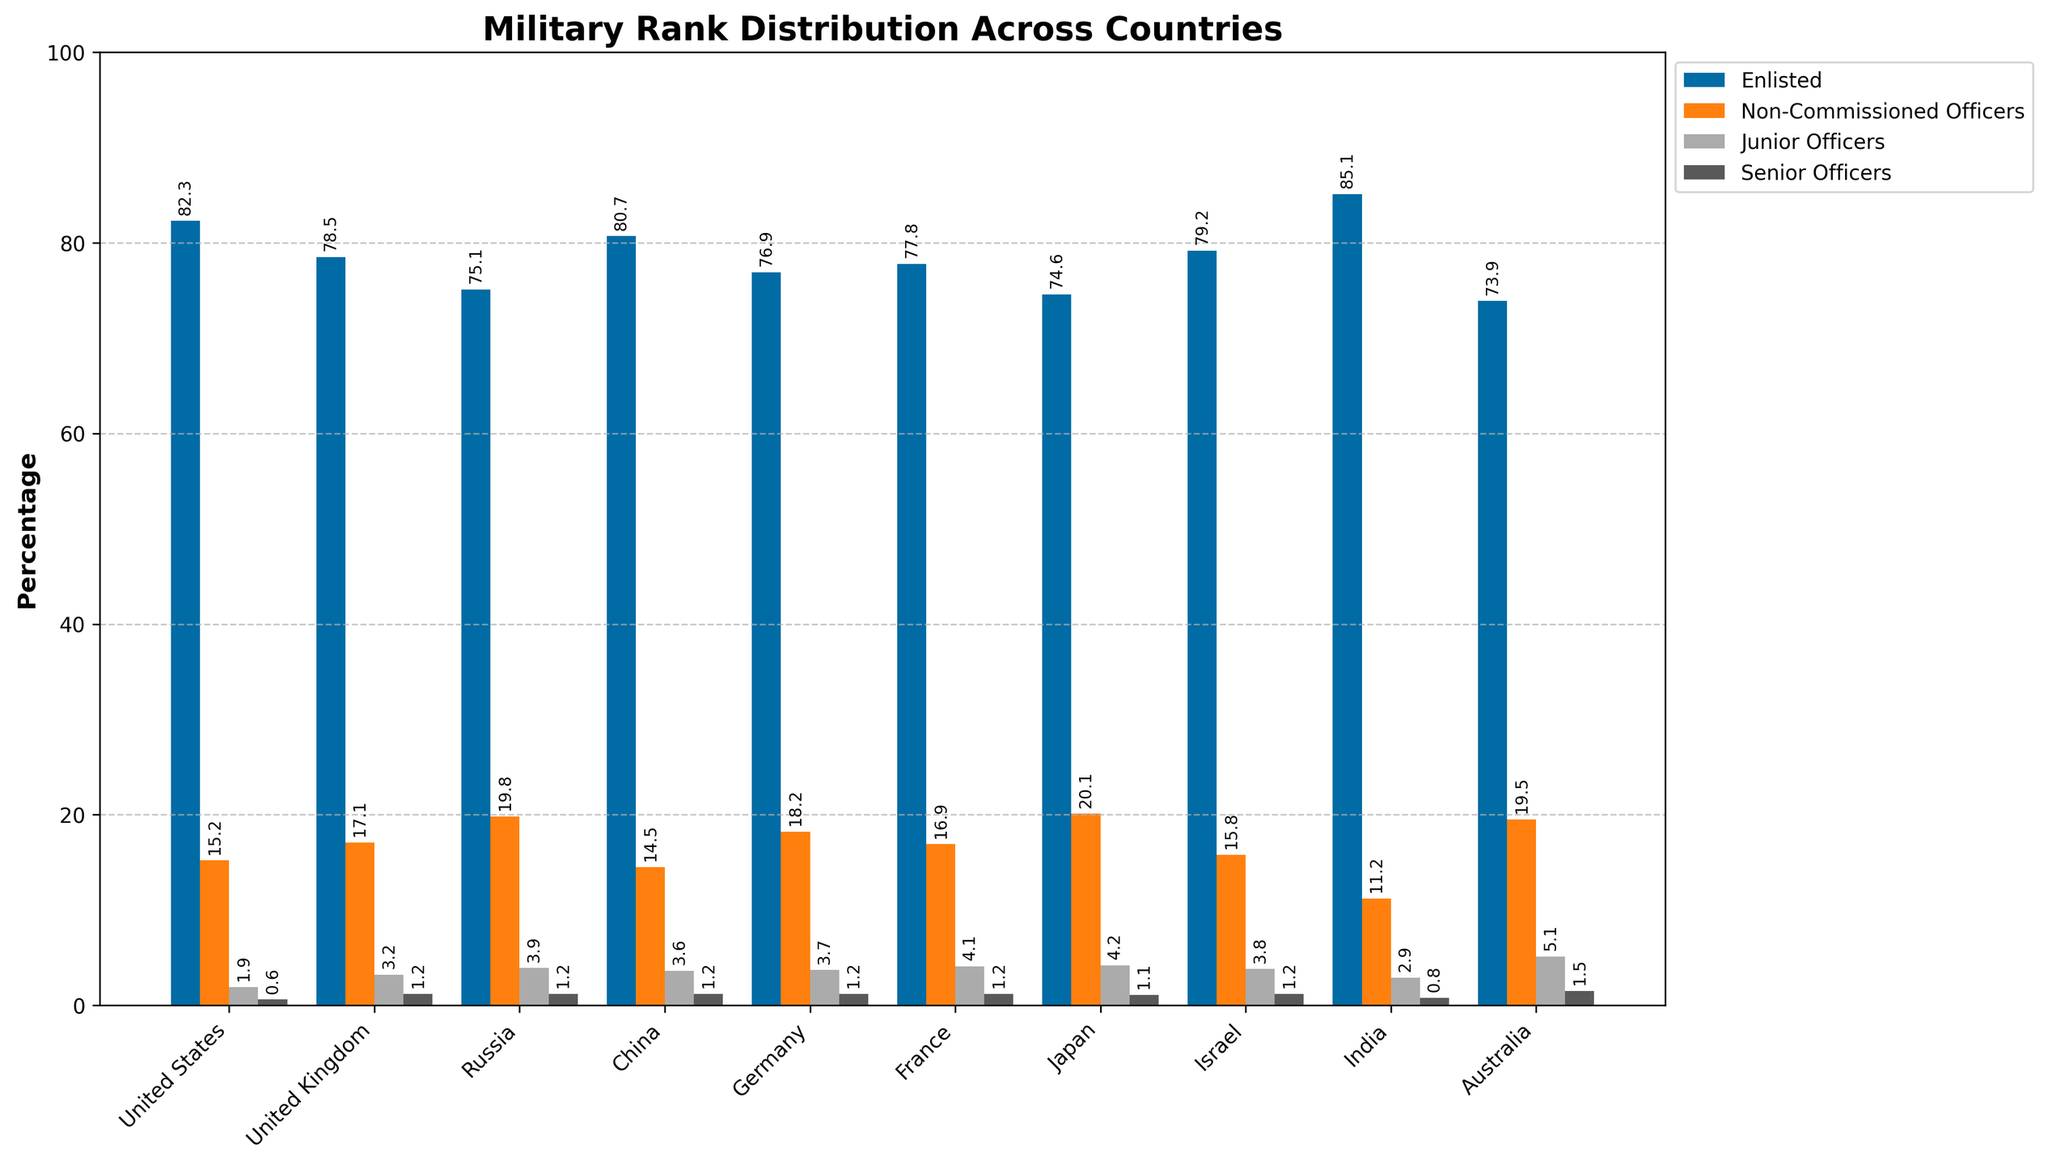Which country has the highest percentage of enlisted personnel? The United States has the highest percentage of enlisted personnel, as indicated by the tallest blue bar in the enlisted category, showing 85.1%.
Answer: United States Which country ranks highest in the proportion of junior officers? Australia has the highest proportion of junior officers. The pinkish bar for junior officers is tallest for Australia, indicating 5.1%.
Answer: Australia Compare the proportion of non-commissioned officers between Russia and Japan. Russia has a lower percentage of non-commissioned officers at 19.8%, compared to Japan's 20.1%. This is shown by the height of the green bars for these countries.
Answer: Japan has a higher proportion What is the total percentage of enlisted personnel and non-commissioned officers in Israel? Adding the percentage of enlisted personnel (79.2%) and non-commissioned officers (15.8%) in Israel gives 79.2 + 15.8 = 95%.
Answer: 95% For which country does the percentage of enlisted personnel and senior officers sum up to closest to 82%? For the United States, adding the percentage of enlisted personnel (82.3%) and senior officers (0.6%) gives 82.9%, which is close to 82%.
Answer: United States Which two countries have an equal proportion of senior officers? The United Kingdom, Russia, China, Germany, France, and Israel all have 1.2% senior officers, as represented by the equal heights of the purple bars in these countries.
Answer: United Kingdom, Russia, China, Germany, France, Israel What is the difference in the percentage of junior officers between France and Germany? France has 4.1% junior officers while Germany has 3.7%. The difference is 4.1% - 3.7% = 0.4%.
Answer: 0.4% Compare the total percentage of non-commissioned officers, junior officers, and senior officers in India with that of Australia. India: 11.2% (NCO) + 2.9% (JO) + 0.8% (SO) = 14.9%. Australia: 19.5% (NCO) + 5.1% (JO) + 1.5% (SO) = 26.1%. Australia has a higher combined percentage.
Answer: Australia has a higher combined percentage How does the percentage of junior officers in the United States compare to that in the United Kingdom? The United Kingdom has a higher percentage of junior officers (3.2%) compared to the United States (1.9%), as indicated by the height of the pinkish bars.
Answer: United Kingdom higher What country has the smallest proportion of enlisted personnel? Australia has the smallest proportion of enlisted personnel at 73.9%, as indicated by the shortest blue bar in the enlisted category.
Answer: Australia 